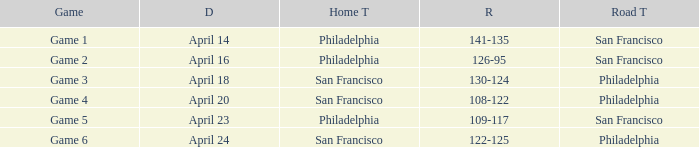When was the second game held? April 16. 